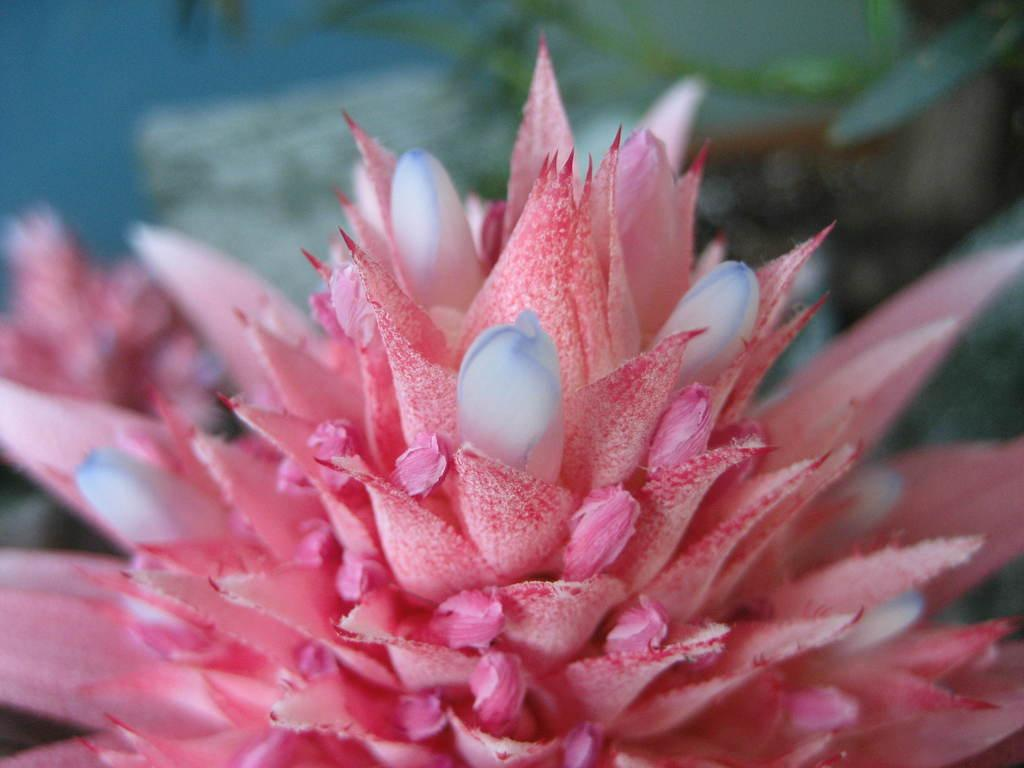What type of flower is in the image? There is a pink and white color flower in the image. Can you describe the background of the image? The background of the image is blurred. What type of glass is being used to hold the snow in the image? There is no glass or snow present in the image; it features a pink and white flower with a blurred background. 